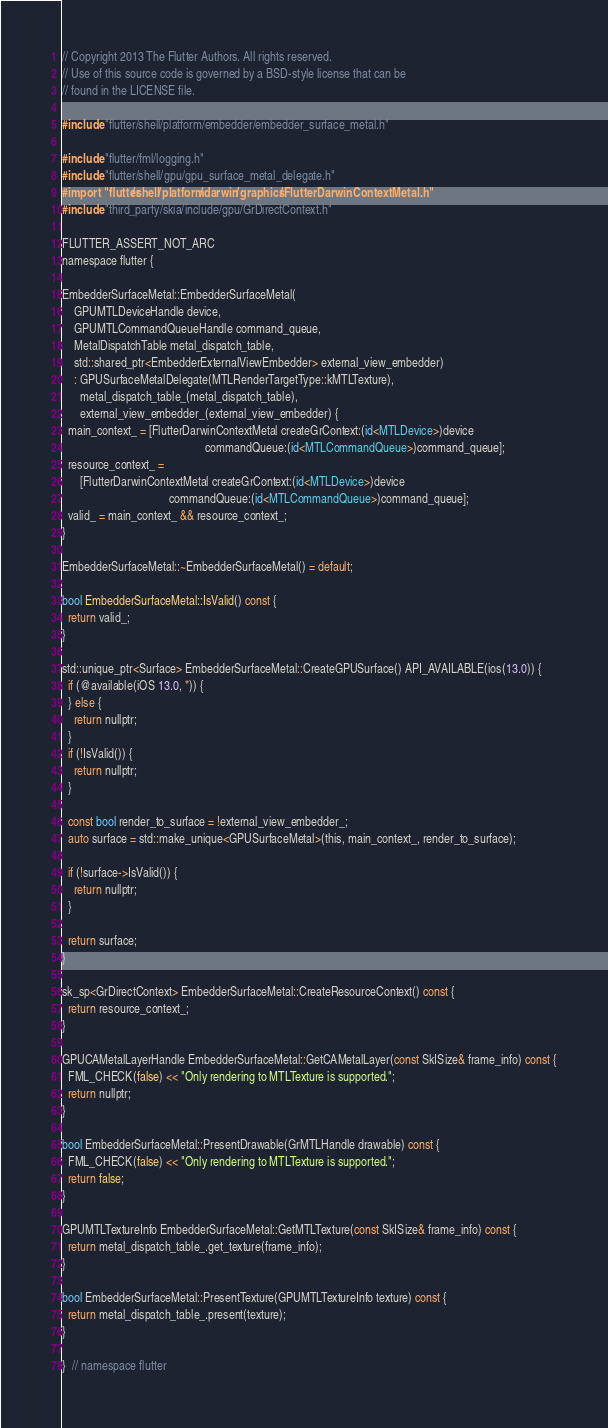<code> <loc_0><loc_0><loc_500><loc_500><_ObjectiveC_>// Copyright 2013 The Flutter Authors. All rights reserved.
// Use of this source code is governed by a BSD-style license that can be
// found in the LICENSE file.

#include "flutter/shell/platform/embedder/embedder_surface_metal.h"

#include "flutter/fml/logging.h"
#include "flutter/shell/gpu/gpu_surface_metal_delegate.h"
#import "flutter/shell/platform/darwin/graphics/FlutterDarwinContextMetal.h"
#include "third_party/skia/include/gpu/GrDirectContext.h"

FLUTTER_ASSERT_NOT_ARC
namespace flutter {

EmbedderSurfaceMetal::EmbedderSurfaceMetal(
    GPUMTLDeviceHandle device,
    GPUMTLCommandQueueHandle command_queue,
    MetalDispatchTable metal_dispatch_table,
    std::shared_ptr<EmbedderExternalViewEmbedder> external_view_embedder)
    : GPUSurfaceMetalDelegate(MTLRenderTargetType::kMTLTexture),
      metal_dispatch_table_(metal_dispatch_table),
      external_view_embedder_(external_view_embedder) {
  main_context_ = [FlutterDarwinContextMetal createGrContext:(id<MTLDevice>)device
                                                commandQueue:(id<MTLCommandQueue>)command_queue];
  resource_context_ =
      [FlutterDarwinContextMetal createGrContext:(id<MTLDevice>)device
                                    commandQueue:(id<MTLCommandQueue>)command_queue];
  valid_ = main_context_ && resource_context_;
}

EmbedderSurfaceMetal::~EmbedderSurfaceMetal() = default;

bool EmbedderSurfaceMetal::IsValid() const {
  return valid_;
}

std::unique_ptr<Surface> EmbedderSurfaceMetal::CreateGPUSurface() API_AVAILABLE(ios(13.0)) {
  if (@available(iOS 13.0, *)) {
  } else {
    return nullptr;
  }
  if (!IsValid()) {
    return nullptr;
  }

  const bool render_to_surface = !external_view_embedder_;
  auto surface = std::make_unique<GPUSurfaceMetal>(this, main_context_, render_to_surface);

  if (!surface->IsValid()) {
    return nullptr;
  }

  return surface;
}

sk_sp<GrDirectContext> EmbedderSurfaceMetal::CreateResourceContext() const {
  return resource_context_;
}

GPUCAMetalLayerHandle EmbedderSurfaceMetal::GetCAMetalLayer(const SkISize& frame_info) const {
  FML_CHECK(false) << "Only rendering to MTLTexture is supported.";
  return nullptr;
}

bool EmbedderSurfaceMetal::PresentDrawable(GrMTLHandle drawable) const {
  FML_CHECK(false) << "Only rendering to MTLTexture is supported.";
  return false;
}

GPUMTLTextureInfo EmbedderSurfaceMetal::GetMTLTexture(const SkISize& frame_info) const {
  return metal_dispatch_table_.get_texture(frame_info);
}

bool EmbedderSurfaceMetal::PresentTexture(GPUMTLTextureInfo texture) const {
  return metal_dispatch_table_.present(texture);
}

}  // namespace flutter
</code> 